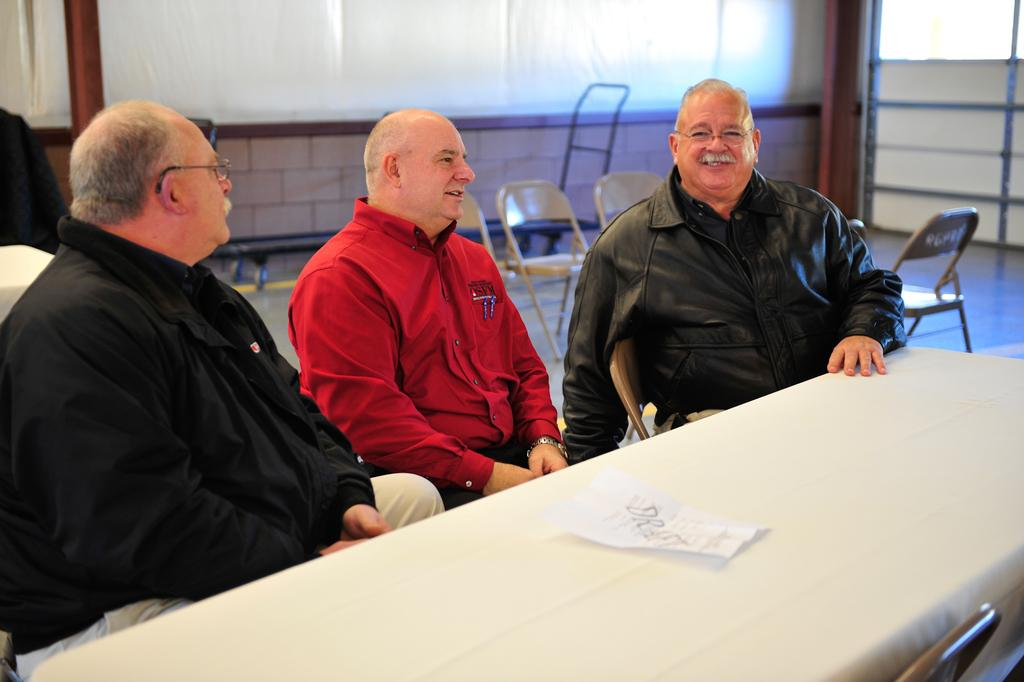What is in the background of the image? There is a whiteboard and empty chairs in the background. What type of surface is the scene taking place on? The scene takes place on a floor. How many men are sitting in the image? There are three men sitting on chairs. What are the men sitting in front of? The men are sitting in front of a table. What is on the table? There is a paper on the table. Can you see the men's faces clearly in the image? The image does not provide a clear view of the men's faces. Is there any indication that the paper on the table is on fire? No, there is no indication that the paper on the table is on fire. 